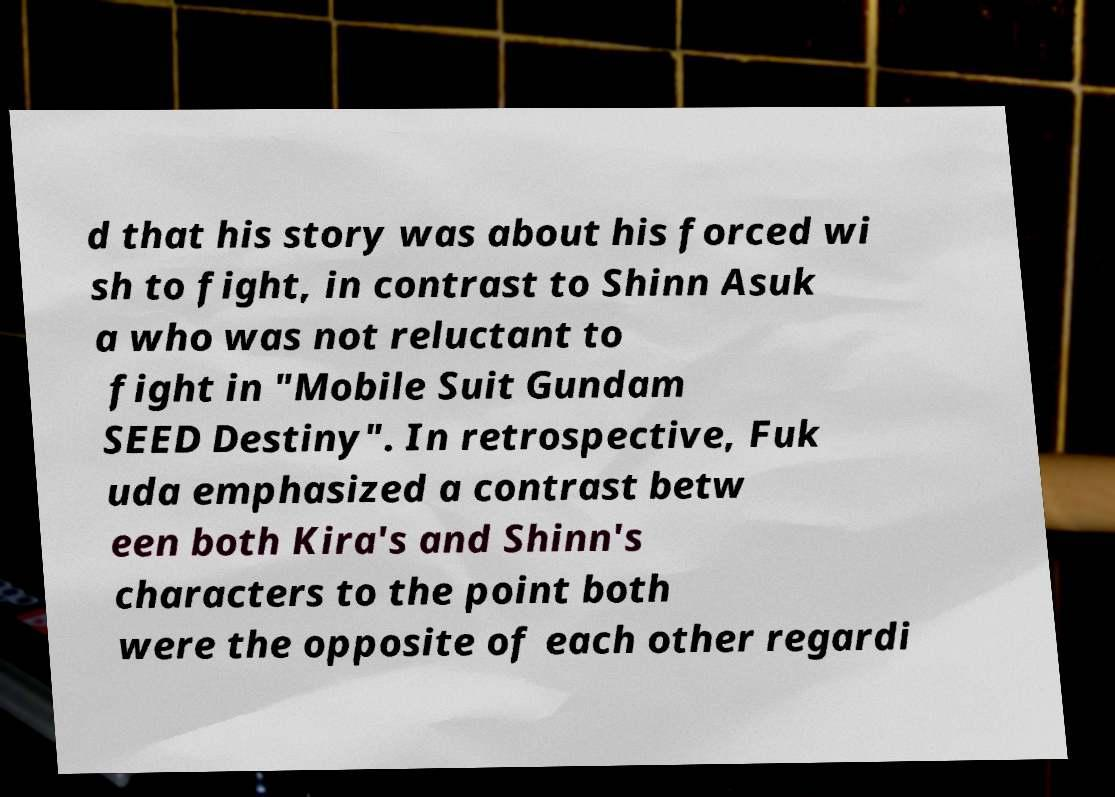For documentation purposes, I need the text within this image transcribed. Could you provide that? d that his story was about his forced wi sh to fight, in contrast to Shinn Asuk a who was not reluctant to fight in "Mobile Suit Gundam SEED Destiny". In retrospective, Fuk uda emphasized a contrast betw een both Kira's and Shinn's characters to the point both were the opposite of each other regardi 